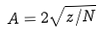Convert formula to latex. <formula><loc_0><loc_0><loc_500><loc_500>A = 2 \sqrt { z / N }</formula> 